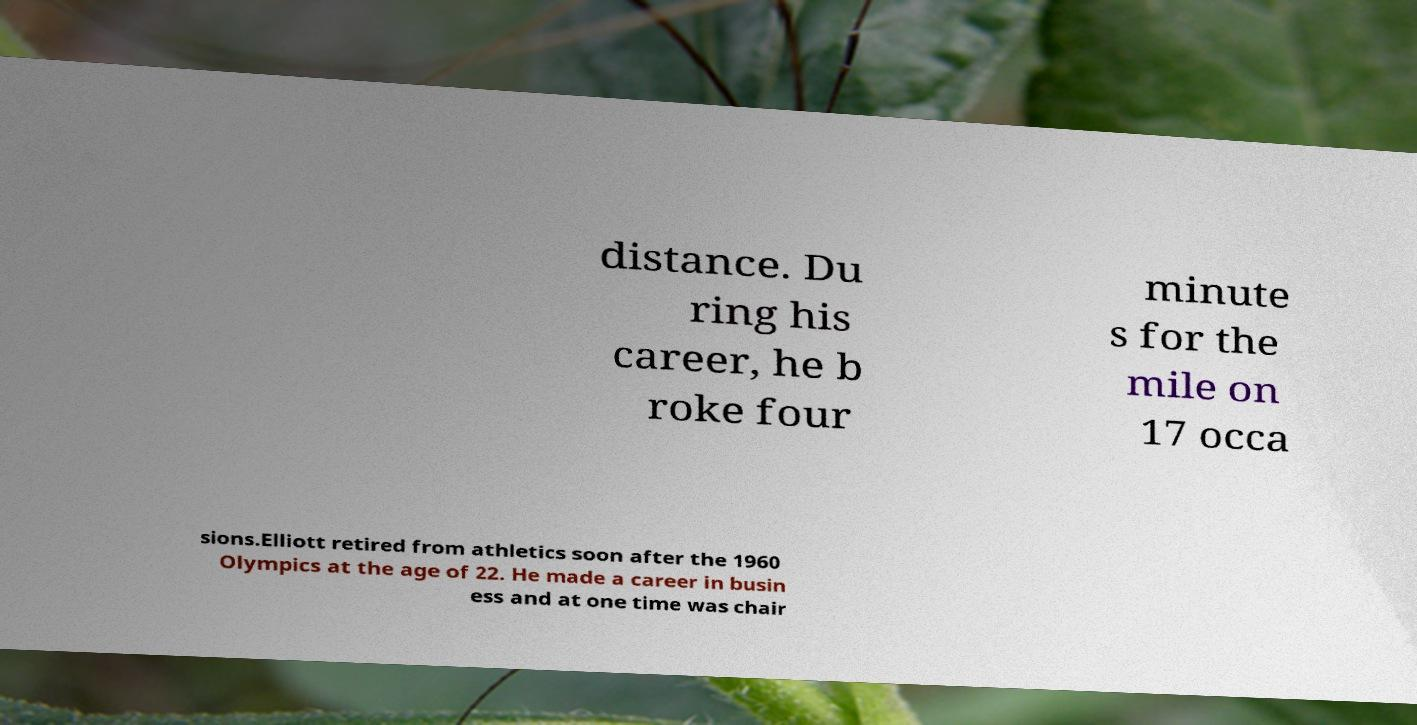Can you read and provide the text displayed in the image?This photo seems to have some interesting text. Can you extract and type it out for me? distance. Du ring his career, he b roke four minute s for the mile on 17 occa sions.Elliott retired from athletics soon after the 1960 Olympics at the age of 22. He made a career in busin ess and at one time was chair 